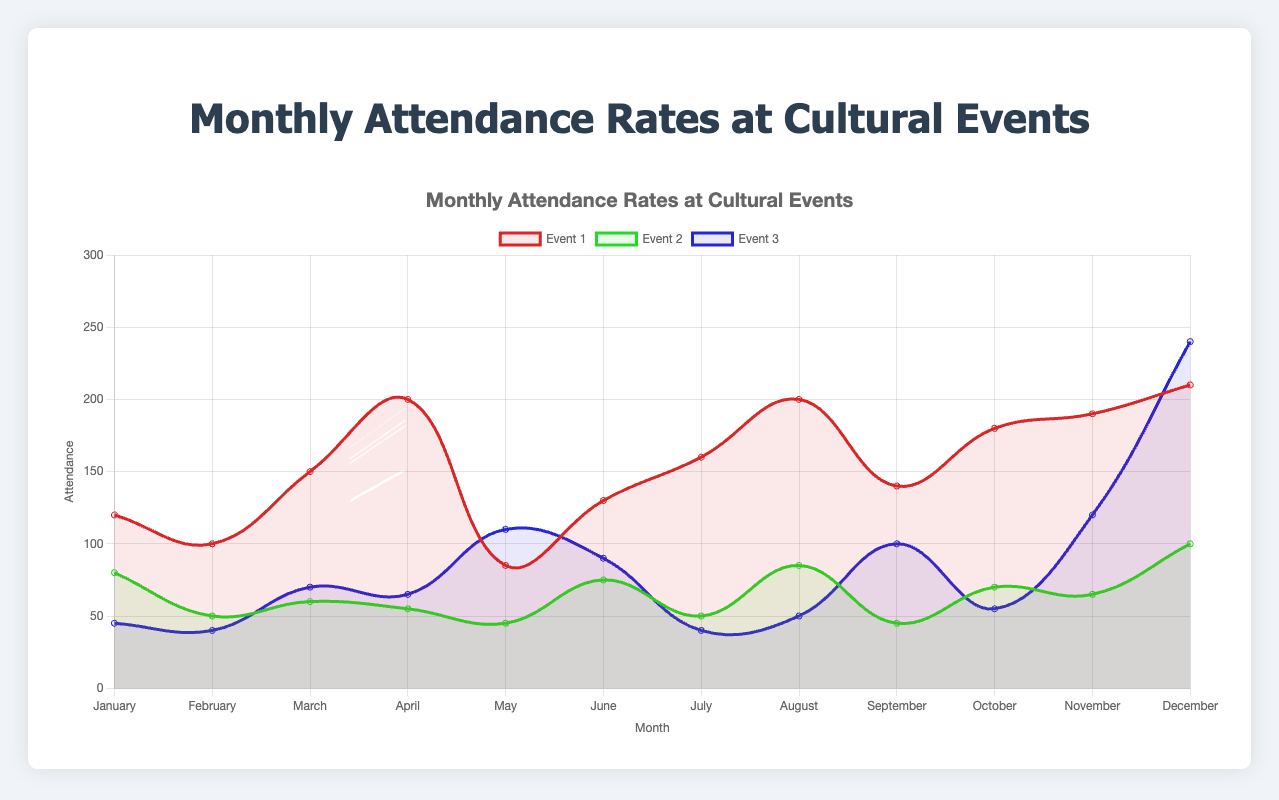What month had the highest attendance for the "New Year Concert"? Look at the line graph and identify the data point corresponding to the "New Year Concert" dataset in January. This point has an attendance of 120.
Answer: January How did the attendance for the "Spring Festival" in March compare to the "Easter Egg Hunt" in April? Locate the data points for the "Spring Festival" and "Easter Egg Hunt". The "Spring Festival" had 150 attendees, while the "Easter Egg Hunt" had 200 attendees. The latter had more attendees.
Answer: The "Easter Egg Hunt" in April had more attendees What is the total attendance for "Photography Exhibition" from August and "Film Screening" from September? Find the attendance for these events: "Photography Exhibition" in August is 85, "Film Screening" in September is 100. Sum these values: 85 + 100 = 185.
Answer: 185 Which event had a higher attendance in July, "Independence Day BBQ" or "Poetry Reading"? Compare the two data points in July. "Independence Day BBQ" had 160 attendees, and "Poetry Reading" had 40. "Independence Day BBQ" had more attendees.
Answer: "Independence Day BBQ" had a higher attendance What is the average attendance of the "Cooking for Kids" event in September and "Calligraphy Class" in May? Look for the attendance values: "Cooking for Kids" in September is 45, and "Calligraphy Class" in May is 45. Calculate the average: (45 + 45) / 2 = 45.
Answer: 45 Is there a month where every event had over 50 attendees? Examine the dataset where every event in the month has more than 50 attendees. April fits this condition ("Easter Egg Hunt" 200, "Painting Workshop" 55, "Local History Talk" 65).
Answer: April In which month did "Christmas Caroling" take place, and what was its attendance? Check the figure for the "Christmas Caroling" attendance and month. The month is December, and attendance is 210.
Answer: December, 210 What is the difference between the highest and lowest attendance for the events in June? Identify the attendance values for June's events: "Summer Solstice Party" 130, "Yoga in the Park" 75, "Craft Fair" 90. The difference is 130 - 75 = 55.
Answer: 55 What are the total attendances of "Local History Talk" in April and "History Lecture" in November? Sum the attendance values: "Local History Talk" in April is 65 and "History Lecture" in November is 65. The total is 65 + 65 = 130.
Answer: 130 Compare the attendance rates of "Holiday Market" in December with "History Lecture" in November. Which was higher? Compare these data points: "Holiday Market" in December had 100 attendees, "History Lecture" in November had 65. The "Holiday Market" had a higher attendance.
Answer: "Holiday Market" had a higher attendance 